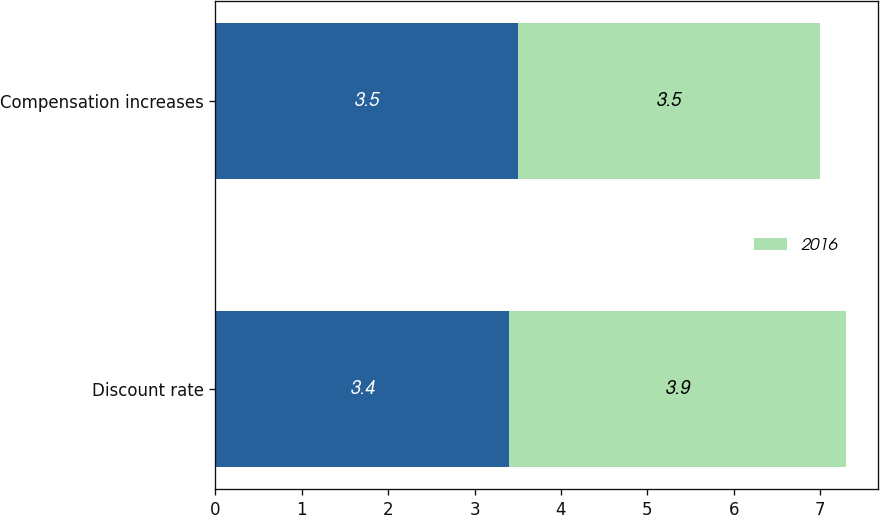Convert chart. <chart><loc_0><loc_0><loc_500><loc_500><stacked_bar_chart><ecel><fcel>Discount rate<fcel>Compensation increases<nl><fcel>nan<fcel>3.4<fcel>3.5<nl><fcel>2016<fcel>3.9<fcel>3.5<nl></chart> 